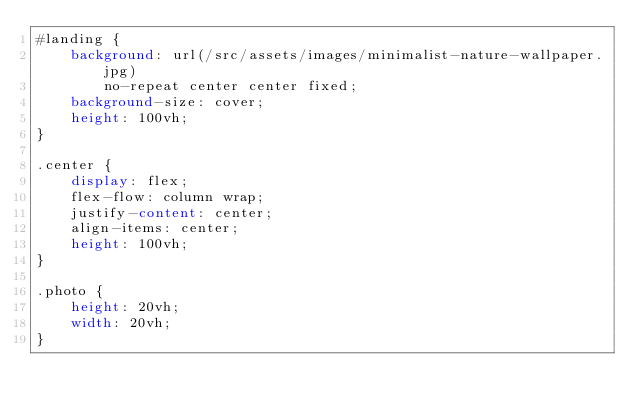Convert code to text. <code><loc_0><loc_0><loc_500><loc_500><_CSS_>#landing {
    background: url(/src/assets/images/minimalist-nature-wallpaper.jpg)
        no-repeat center center fixed;
    background-size: cover;
    height: 100vh;
}

.center {
    display: flex;
    flex-flow: column wrap;
    justify-content: center;
    align-items: center;
    height: 100vh;
}

.photo {
    height: 20vh;
    width: 20vh;
}
</code> 